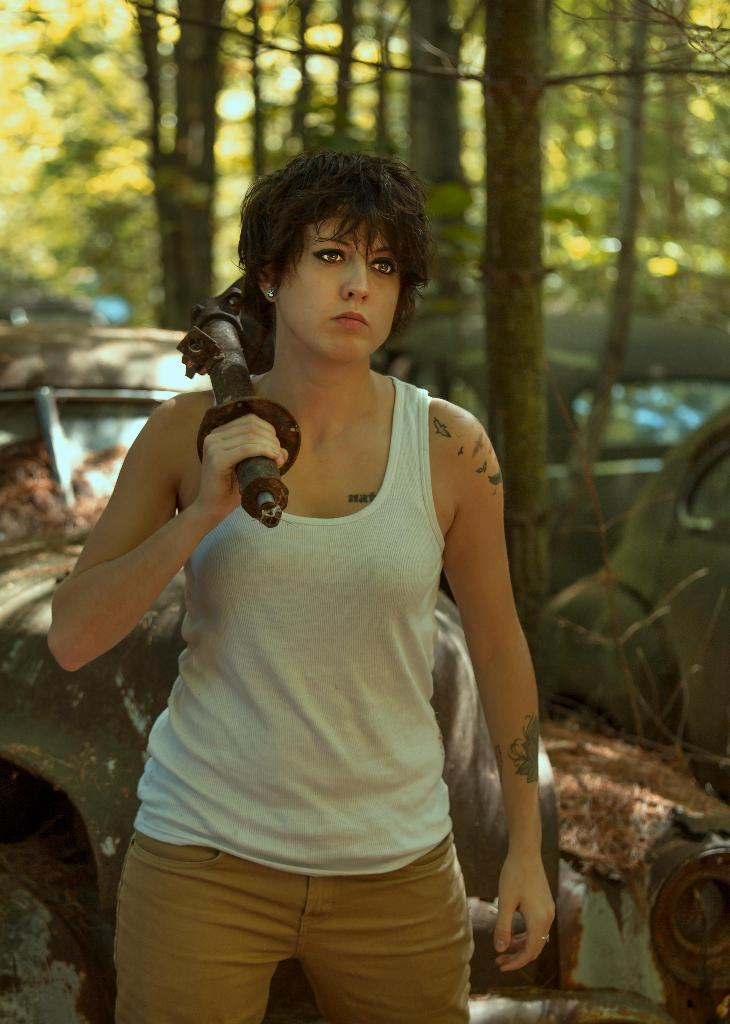Who is present in the image? There is a woman in the image. What is the woman holding in the image? The woman is holding an iron object. What is the woman's posture in the image? The woman is standing in the image. What can be seen in the background of the image? There are cars and trees in the background of the image. How many friends is the woman talking to in the image? There is no indication of any friends in the image; it only features a woman holding an iron object and standing. What type of farming equipment can be seen in the image? There is no farming equipment present in the image. 